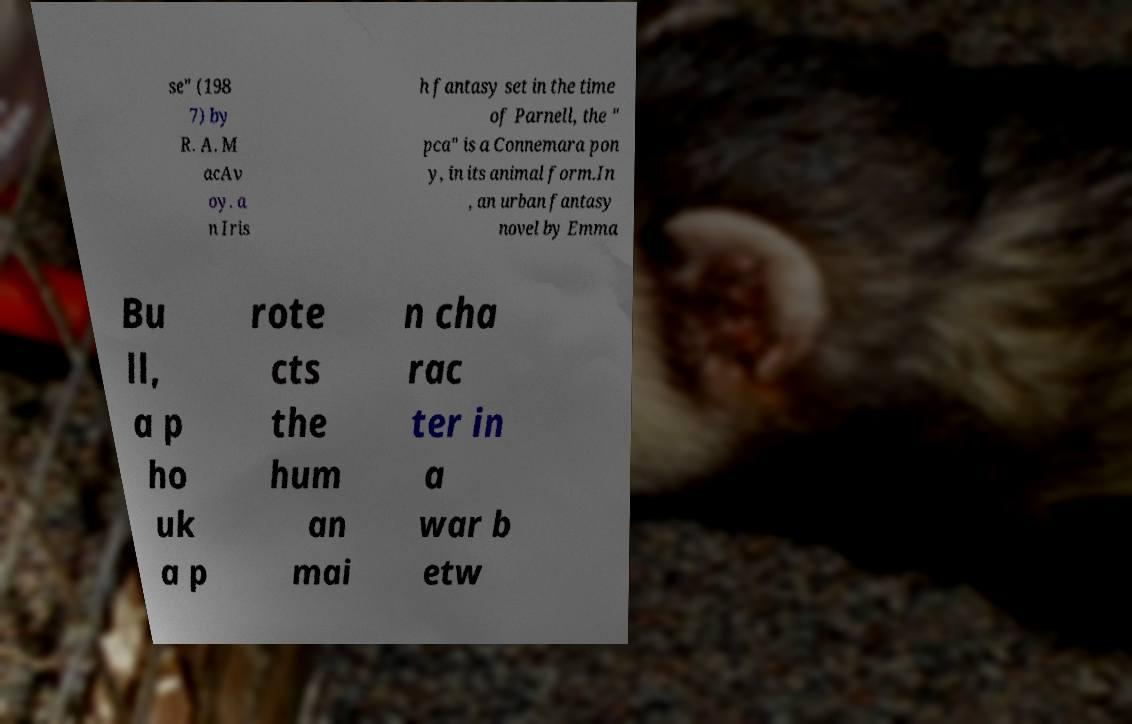I need the written content from this picture converted into text. Can you do that? se" (198 7) by R. A. M acAv oy. a n Iris h fantasy set in the time of Parnell, the " pca" is a Connemara pon y, in its animal form.In , an urban fantasy novel by Emma Bu ll, a p ho uk a p rote cts the hum an mai n cha rac ter in a war b etw 